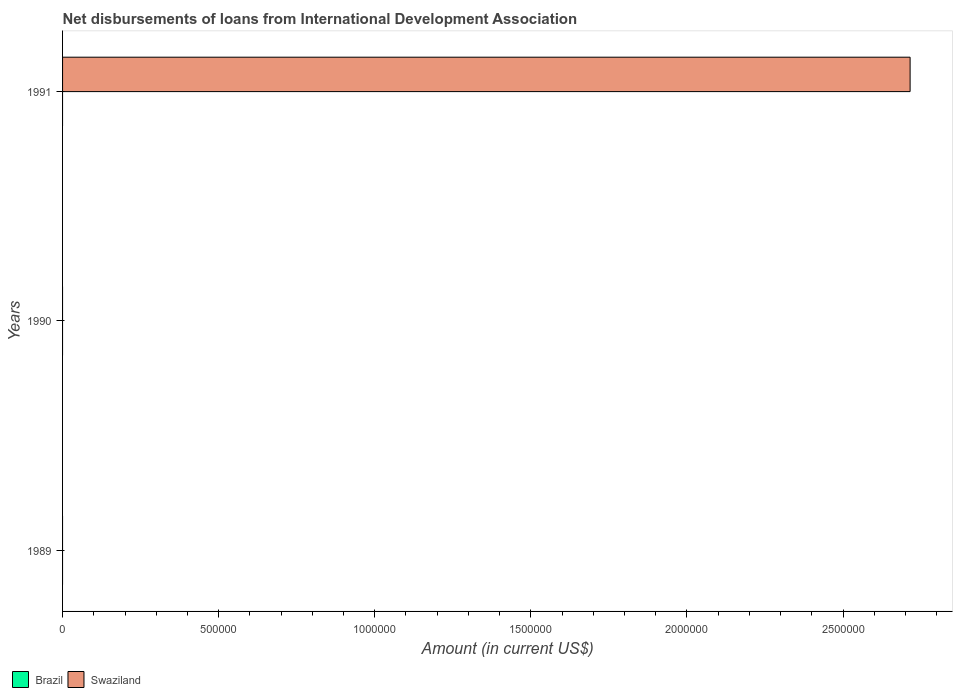How many different coloured bars are there?
Give a very brief answer. 1. Are the number of bars on each tick of the Y-axis equal?
Give a very brief answer. No. How many bars are there on the 3rd tick from the top?
Offer a terse response. 0. What is the amount of loans disbursed in Swaziland in 1991?
Your answer should be very brief. 2.72e+06. Across all years, what is the maximum amount of loans disbursed in Swaziland?
Your answer should be very brief. 2.72e+06. In which year was the amount of loans disbursed in Swaziland maximum?
Offer a terse response. 1991. What is the total amount of loans disbursed in Swaziland in the graph?
Keep it short and to the point. 2.72e+06. What is the difference between the amount of loans disbursed in Swaziland in 1991 and the amount of loans disbursed in Brazil in 1989?
Ensure brevity in your answer.  2.72e+06. What is the average amount of loans disbursed in Brazil per year?
Your answer should be very brief. 0. In how many years, is the amount of loans disbursed in Brazil greater than 700000 US$?
Make the answer very short. 0. What is the difference between the highest and the lowest amount of loans disbursed in Swaziland?
Give a very brief answer. 2.72e+06. In how many years, is the amount of loans disbursed in Brazil greater than the average amount of loans disbursed in Brazil taken over all years?
Offer a terse response. 0. Are all the bars in the graph horizontal?
Provide a short and direct response. Yes. How many years are there in the graph?
Provide a short and direct response. 3. Are the values on the major ticks of X-axis written in scientific E-notation?
Keep it short and to the point. No. Does the graph contain any zero values?
Your answer should be very brief. Yes. Does the graph contain grids?
Your answer should be compact. No. Where does the legend appear in the graph?
Make the answer very short. Bottom left. How many legend labels are there?
Provide a succinct answer. 2. How are the legend labels stacked?
Keep it short and to the point. Horizontal. What is the title of the graph?
Your response must be concise. Net disbursements of loans from International Development Association. What is the label or title of the X-axis?
Provide a short and direct response. Amount (in current US$). What is the label or title of the Y-axis?
Your answer should be compact. Years. What is the Amount (in current US$) of Brazil in 1990?
Provide a succinct answer. 0. What is the Amount (in current US$) in Brazil in 1991?
Your answer should be very brief. 0. What is the Amount (in current US$) of Swaziland in 1991?
Make the answer very short. 2.72e+06. Across all years, what is the maximum Amount (in current US$) of Swaziland?
Your answer should be very brief. 2.72e+06. Across all years, what is the minimum Amount (in current US$) in Swaziland?
Ensure brevity in your answer.  0. What is the total Amount (in current US$) in Swaziland in the graph?
Your response must be concise. 2.72e+06. What is the average Amount (in current US$) in Brazil per year?
Your answer should be very brief. 0. What is the average Amount (in current US$) of Swaziland per year?
Keep it short and to the point. 9.05e+05. What is the difference between the highest and the lowest Amount (in current US$) in Swaziland?
Your response must be concise. 2.72e+06. 